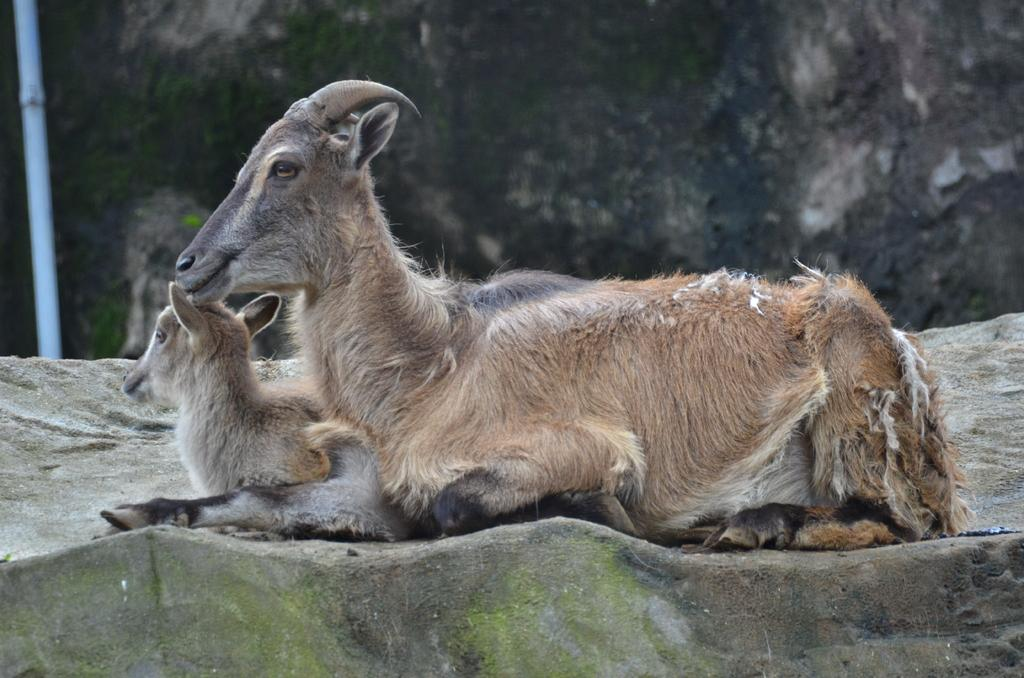How many animals are present in the image? There are two animals in the image. What are the animals doing in the image? The animals are sitting on a rock. What type of mine can be seen in the background of the image? There is no mine present in the image; it only features two animals sitting on a rock. 